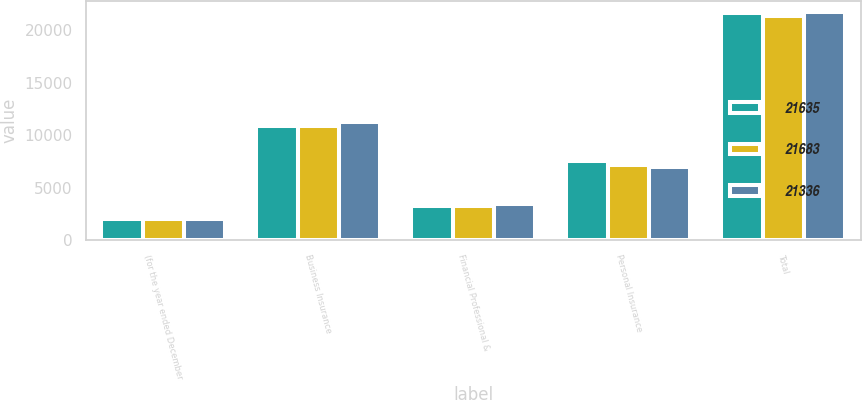Convert chart. <chart><loc_0><loc_0><loc_500><loc_500><stacked_bar_chart><ecel><fcel>(for the year ended December<fcel>Business Insurance<fcel>Financial Professional &<fcel>Personal Insurance<fcel>Total<nl><fcel>21635<fcel>2010<fcel>10857<fcel>3211<fcel>7567<fcel>21635<nl><fcel>21683<fcel>2009<fcel>10902<fcel>3285<fcel>7149<fcel>21336<nl><fcel>21336<fcel>2008<fcel>11220<fcel>3468<fcel>6995<fcel>21683<nl></chart> 